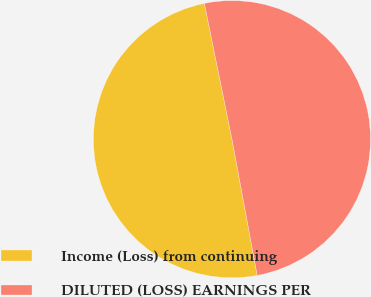Convert chart to OTSL. <chart><loc_0><loc_0><loc_500><loc_500><pie_chart><fcel>Income (Loss) from continuing<fcel>DILUTED (LOSS) EARNINGS PER<nl><fcel>49.73%<fcel>50.27%<nl></chart> 